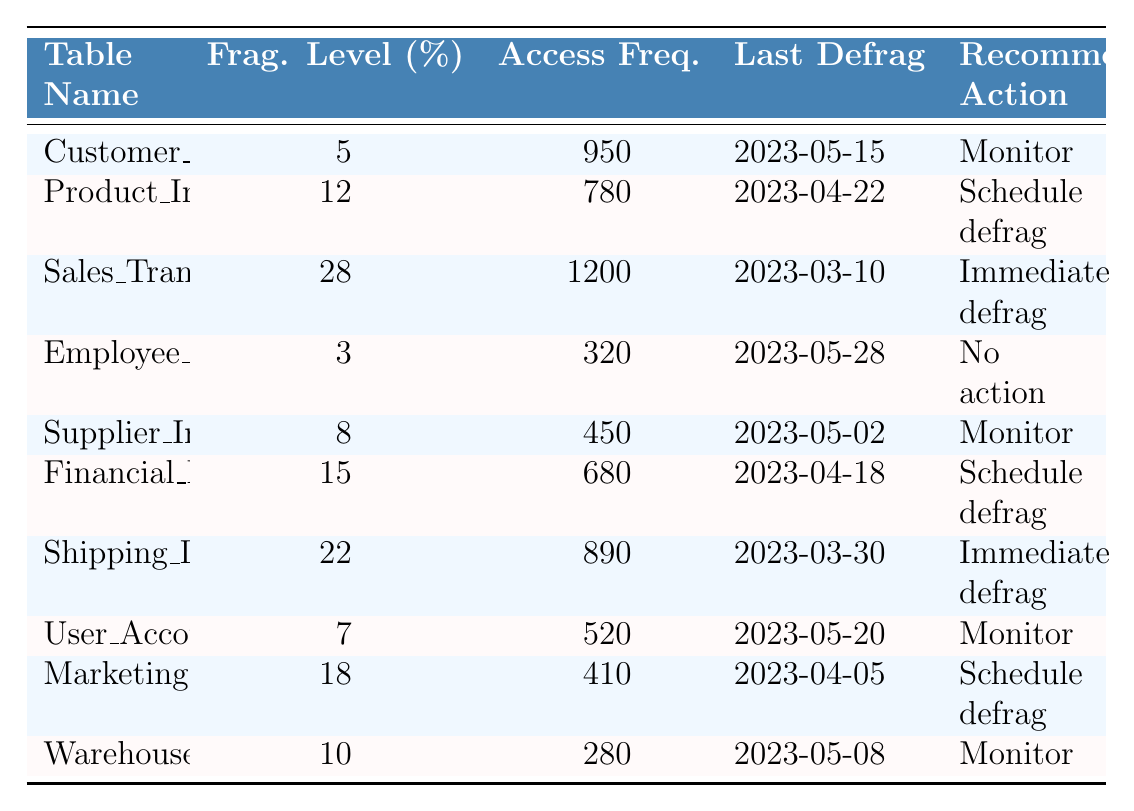What is the fragmentation level of the Sales_Transactions table? The Sales_Transactions table has a fragmentation level of 28%, which can be found directly in the table under the Frag. Level column for that table.
Answer: 28% Which table has the highest access frequency? The Sales_Transactions table has the highest access frequency of 1200, identifiable from the Access Freq. column.
Answer: Sales_Transactions Is there any table that requires immediate defragmentation? Yes, both the Sales_Transactions and Shipping_Details tables require immediate defragmentation, as indicated by "Immediate defrag" in the Recommended Action column.
Answer: Yes What is the average fragmentation level of the tables with access frequency over 500? The tables with access frequency over 500 are Customer_Orders (5%), Sales_Transactions (28%), Shipping_Details (22%), User_Accounts (7%), and Financial_Ledger (15%). Their total fragmentation is 5 + 28 + 22 + 7 + 15 = 77%. There are 5 tables, so the average fragmentation level is 77/5 = 15.4%.
Answer: 15.4% Which table has the most recent defragmentation date? The Employee_Records table has the most recent defragmentation date of 2023-05-28 which is the latest date in the Last Defrag column.
Answer: Employee_Records What is the recommended action for the Product_Inventory table? The recommended action for the Product_Inventory table is to "Schedule defrag," which is stated in the Recommended Action column.
Answer: Schedule defrag How many tables have a fragmentation level greater than 15%? The tables with fragmentation levels greater than 15% are Sales_Transactions (28%), Financial_Ledger (15%), and Shipping_Details (22%). This totals 3 tables.
Answer: 3 What is the total access frequency of the tables that do not require any action? The tables that do not require any action are Employee_Records (320), Customer_Orders (950), User_Accounts (520), and Warehouse_Locations (280). Adding these gives 320 + 950 + 520 + 280 = 2070.
Answer: 2070 Which recommended action is suggested most frequently across all tables? The action "Schedule defrag" appears 4 times for Product_Inventory, Financial_Ledger, Shipping_Details, and Marketing_Campaigns. This is the most frequent recommended action.
Answer: Schedule defrag What is the difference in access frequency between the table with the highest and lowest access frequencies? The highest access frequency is 1200 for the Sales_Transactions table, and the lowest is 280 for the Warehouse_Locations table. The difference is 1200 - 280 = 920.
Answer: 920 